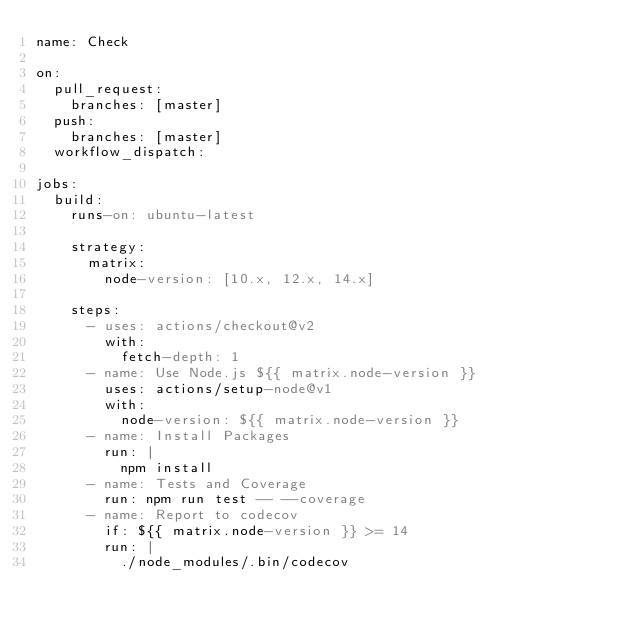Convert code to text. <code><loc_0><loc_0><loc_500><loc_500><_YAML_>name: Check

on:
  pull_request:
    branches: [master]
  push:
    branches: [master]
  workflow_dispatch:

jobs:
  build:
    runs-on: ubuntu-latest

    strategy:
      matrix:
        node-version: [10.x, 12.x, 14.x]

    steps:
      - uses: actions/checkout@v2
        with:
          fetch-depth: 1
      - name: Use Node.js ${{ matrix.node-version }}
        uses: actions/setup-node@v1
        with:
          node-version: ${{ matrix.node-version }}
      - name: Install Packages
        run: |
          npm install
      - name: Tests and Coverage
        run: npm run test -- --coverage
      - name: Report to codecov
        if: ${{ matrix.node-version }} >= 14
        run: |
          ./node_modules/.bin/codecov
</code> 